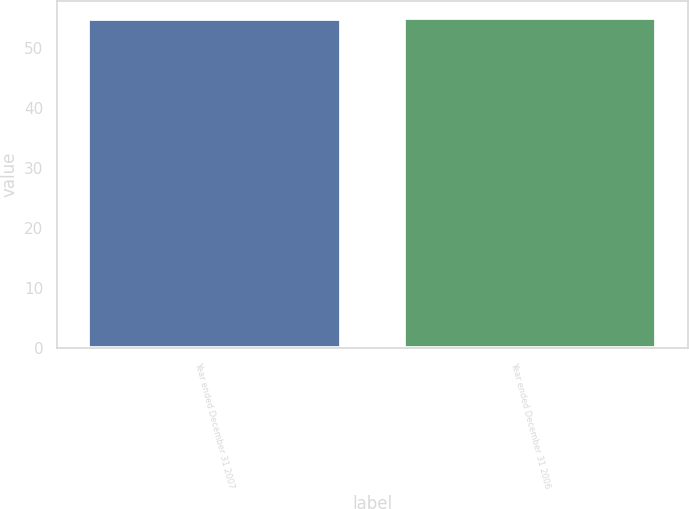Convert chart. <chart><loc_0><loc_0><loc_500><loc_500><bar_chart><fcel>Year ended December 31 2007<fcel>Year ended December 31 2006<nl><fcel>55<fcel>55.1<nl></chart> 